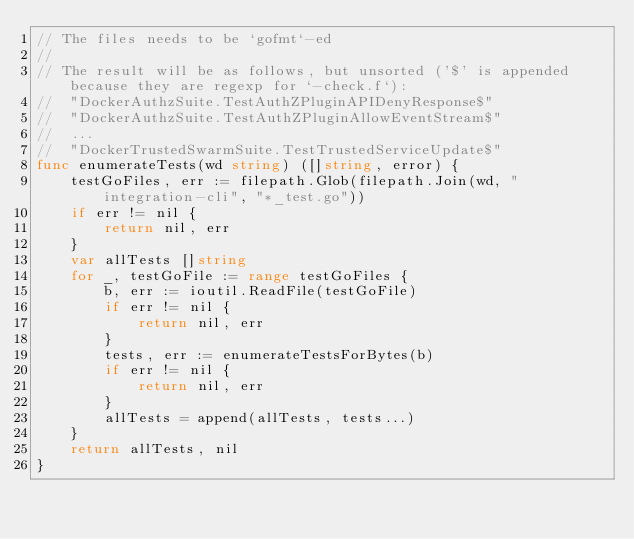Convert code to text. <code><loc_0><loc_0><loc_500><loc_500><_Go_>// The files needs to be `gofmt`-ed
//
// The result will be as follows, but unsorted ('$' is appended because they are regexp for `-check.f`):
//  "DockerAuthzSuite.TestAuthZPluginAPIDenyResponse$"
//  "DockerAuthzSuite.TestAuthZPluginAllowEventStream$"
//  ...
//  "DockerTrustedSwarmSuite.TestTrustedServiceUpdate$"
func enumerateTests(wd string) ([]string, error) {
	testGoFiles, err := filepath.Glob(filepath.Join(wd, "integration-cli", "*_test.go"))
	if err != nil {
		return nil, err
	}
	var allTests []string
	for _, testGoFile := range testGoFiles {
		b, err := ioutil.ReadFile(testGoFile)
		if err != nil {
			return nil, err
		}
		tests, err := enumerateTestsForBytes(b)
		if err != nil {
			return nil, err
		}
		allTests = append(allTests, tests...)
	}
	return allTests, nil
}
</code> 